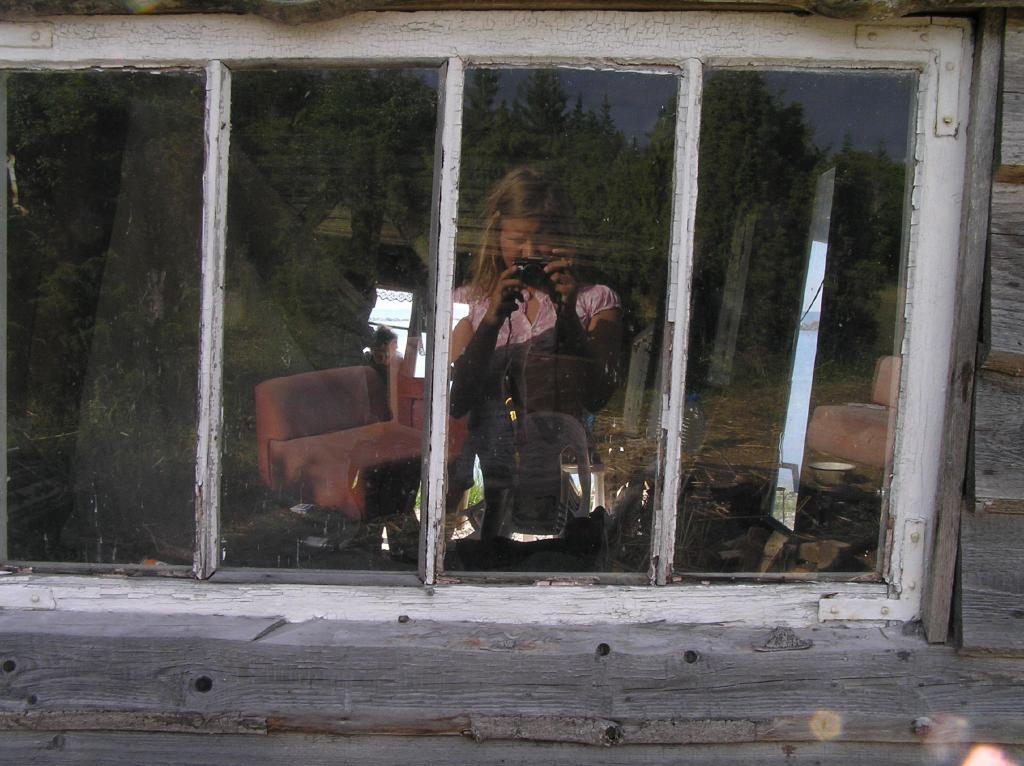What is the main subject of the image? The main subject of the image is a window glass. What can be seen in the reflections on the window glass? The reflections of trees, the sky, a woman holding an object, a chair, and other objects are visible in the window glass. What type of wall is present in the image? There is a wooden wall in the image. What type of event is happening outside the window in the image? There is no event happening outside the window in the image; the conversation focuses on the reflections visible on the window glass. Can you describe the stranger standing next to the woman in the image? There is no stranger present in the image; the reflection shows a woman holding an object. 